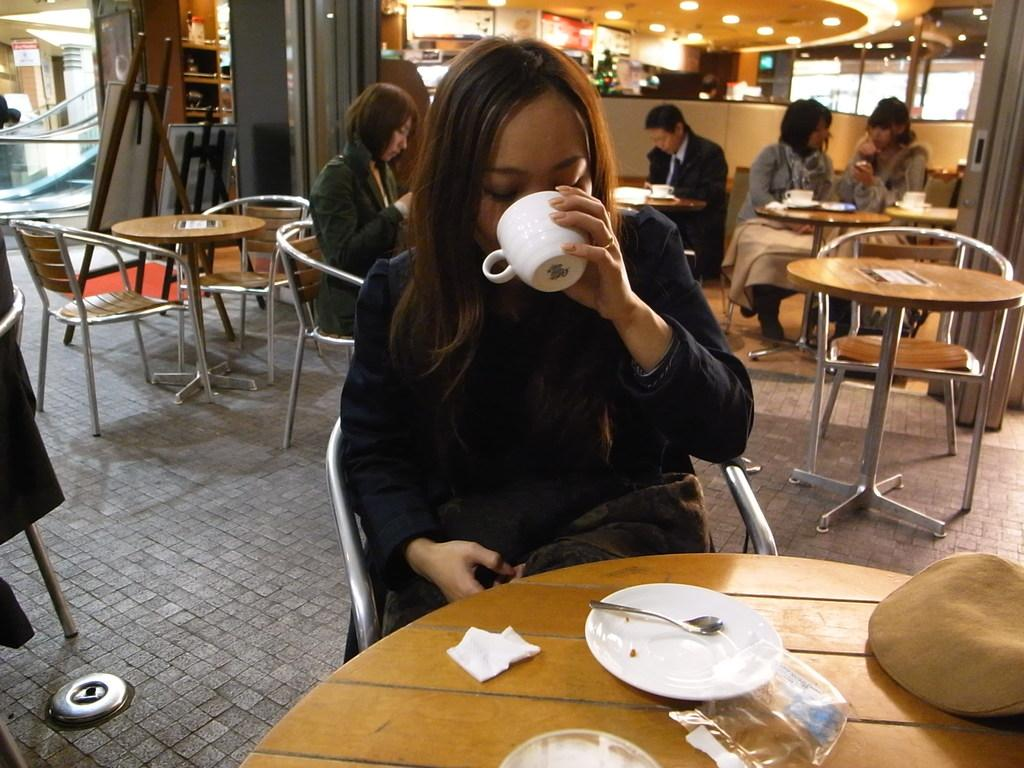What is the woman in the image doing? The woman is seated and drinking coffee in the image. What is the woman holding in the image? The woman is holding a coffee cup in the image. Are there any other objects related to the coffee on the table? Yes, there is a saucer and a spoon on the table in the image. What is unusual about the woman's situation in the image? There are people seated on the woman's back in the image. What type of bells can be heard ringing in the image? There are no bells present in the image, and therefore no sound can be heard. How does the woman's father react to the situation in the image? There is no father present in the image, and the woman's reaction to the situation is not mentioned. 